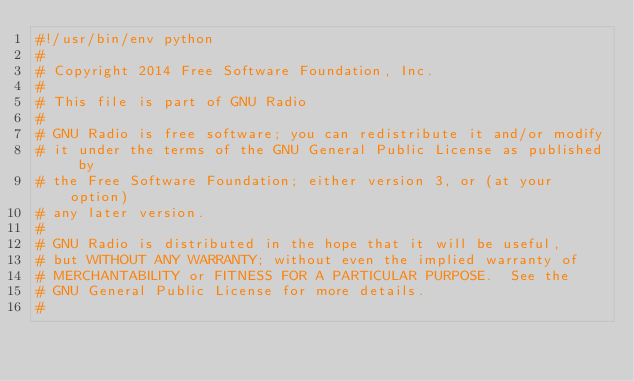<code> <loc_0><loc_0><loc_500><loc_500><_Python_>#!/usr/bin/env python
#
# Copyright 2014 Free Software Foundation, Inc.
#
# This file is part of GNU Radio
#
# GNU Radio is free software; you can redistribute it and/or modify
# it under the terms of the GNU General Public License as published by
# the Free Software Foundation; either version 3, or (at your option)
# any later version.
#
# GNU Radio is distributed in the hope that it will be useful,
# but WITHOUT ANY WARRANTY; without even the implied warranty of
# MERCHANTABILITY or FITNESS FOR A PARTICULAR PURPOSE.  See the
# GNU General Public License for more details.
#</code> 